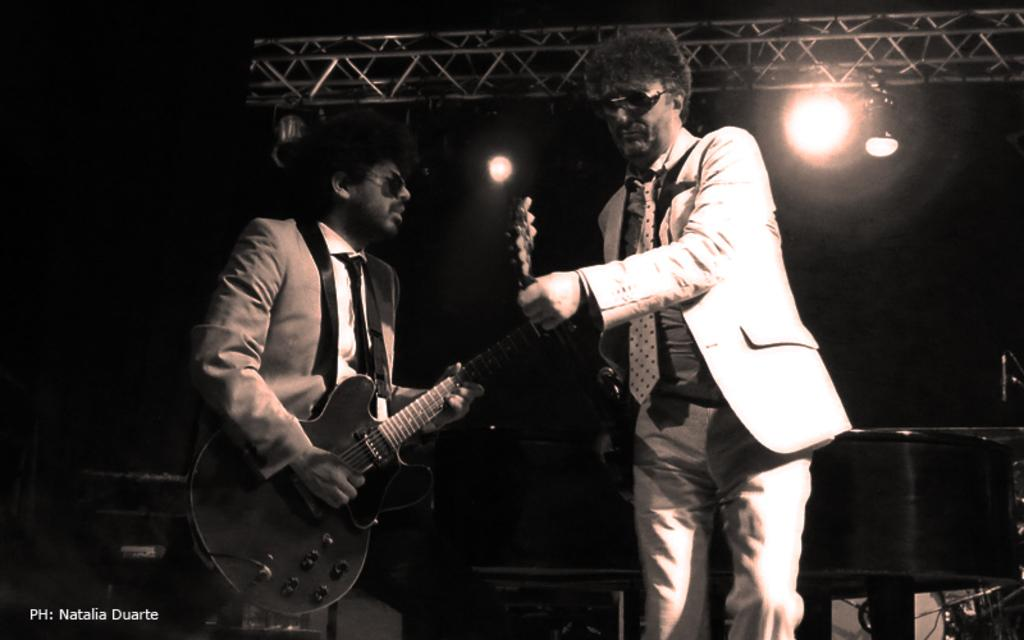How many people are in the image? There are two men in the image. What is one of the men doing in the image? One man is playing a guitar. What is the other man doing in the image? The other man is standing. What can be seen in the background of the image? There are pillars and lights in the background of the image. What type of engine can be seen in the image? There is no engine present in the image. Is there a quill being used for writing in the image? There is no quill or writing activity depicted in the image. 